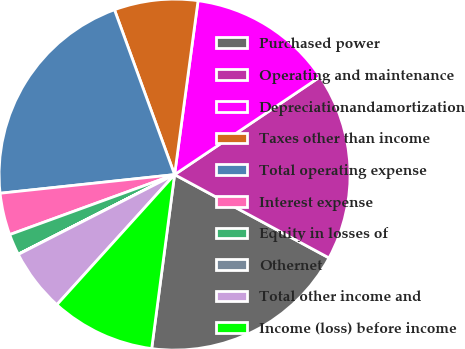Convert chart to OTSL. <chart><loc_0><loc_0><loc_500><loc_500><pie_chart><fcel>Purchased power<fcel>Operating and maintenance<fcel>Depreciationandamortization<fcel>Taxes other than income<fcel>Total operating expense<fcel>Interest expense<fcel>Equity in losses of<fcel>Othernet<fcel>Total other income and<fcel>Income (loss) before income<nl><fcel>19.21%<fcel>17.29%<fcel>13.45%<fcel>7.7%<fcel>21.13%<fcel>3.86%<fcel>1.94%<fcel>0.02%<fcel>5.78%<fcel>9.62%<nl></chart> 